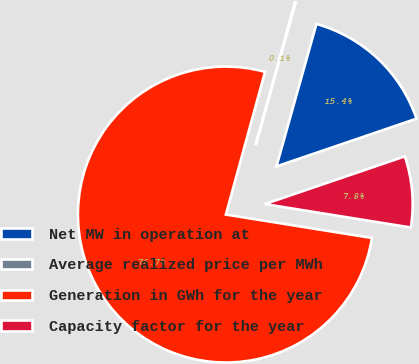<chart> <loc_0><loc_0><loc_500><loc_500><pie_chart><fcel>Net MW in operation at<fcel>Average realized price per MWh<fcel>Generation in GWh for the year<fcel>Capacity factor for the year<nl><fcel>15.42%<fcel>0.09%<fcel>76.73%<fcel>7.76%<nl></chart> 